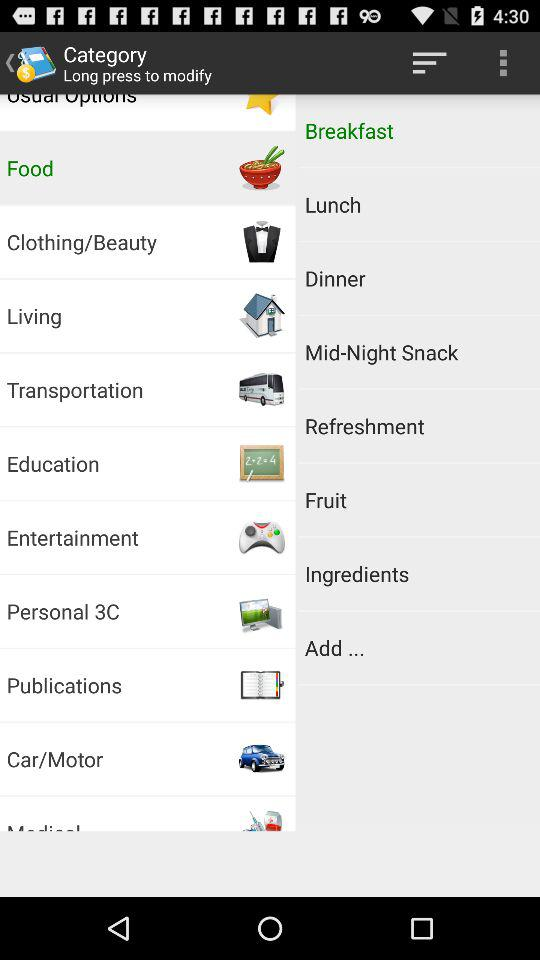Which breakfast recipe is selected?
When the provided information is insufficient, respond with <no answer>. <no answer> 